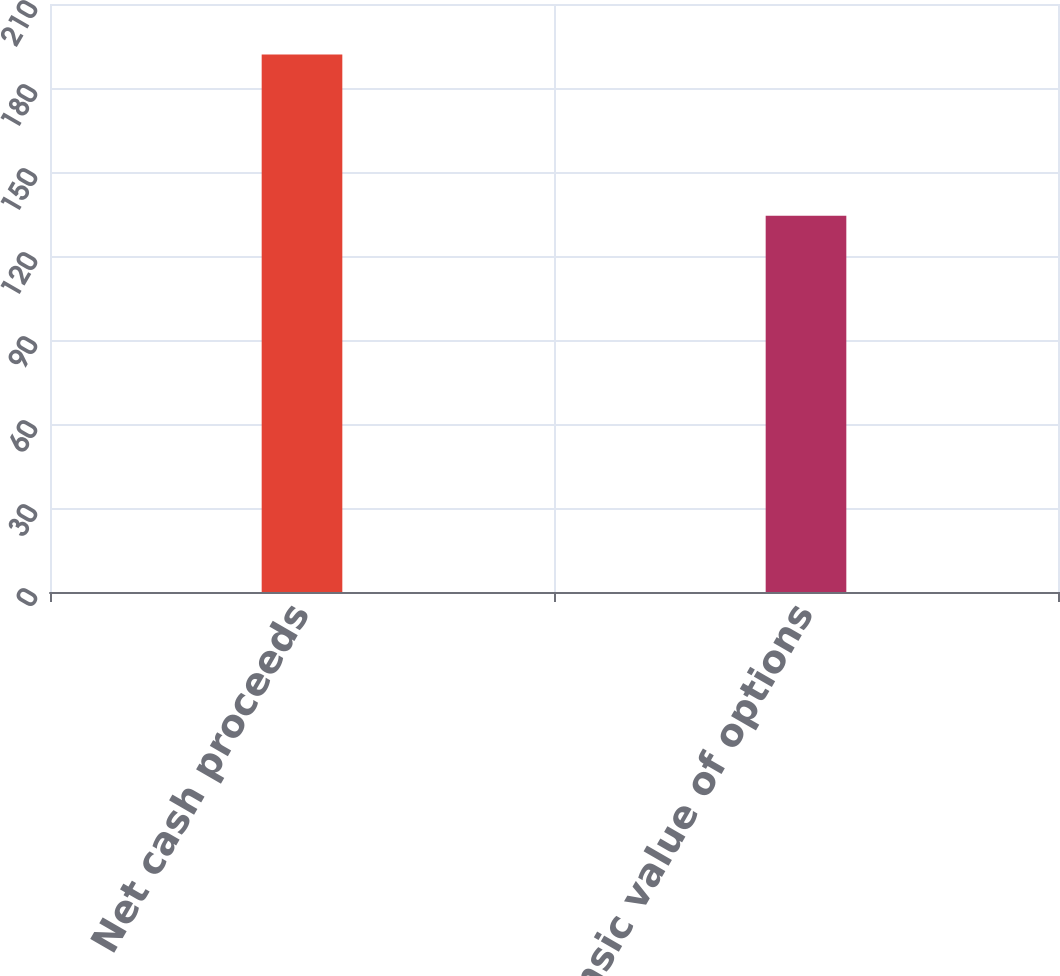Convert chart. <chart><loc_0><loc_0><loc_500><loc_500><bar_chart><fcel>Net cash proceeds<fcel>Intrinsic value of options<nl><fcel>192<fcel>134.4<nl></chart> 